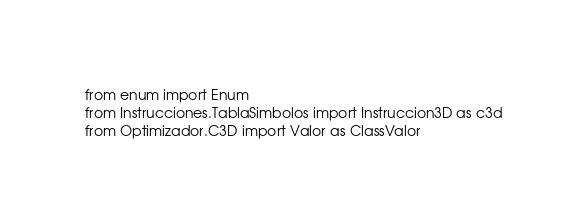<code> <loc_0><loc_0><loc_500><loc_500><_Python_>from enum import Enum
from Instrucciones.TablaSimbolos import Instruccion3D as c3d
from Optimizador.C3D import Valor as ClassValor</code> 